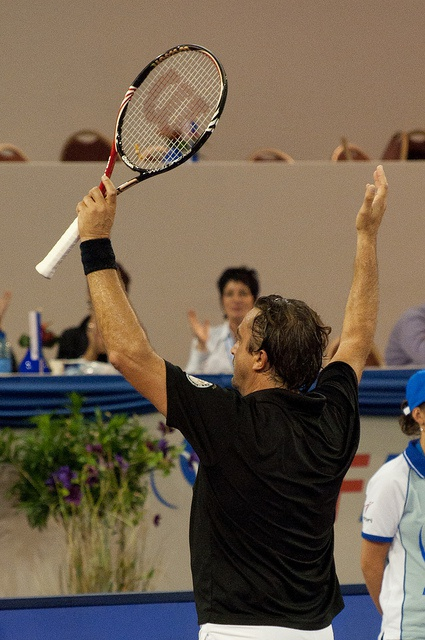Describe the objects in this image and their specific colors. I can see people in gray, black, brown, and tan tones, tennis racket in gray, tan, and black tones, people in gray, lightgray, darkgray, blue, and brown tones, people in gray, darkgray, black, and tan tones, and people in gray tones in this image. 